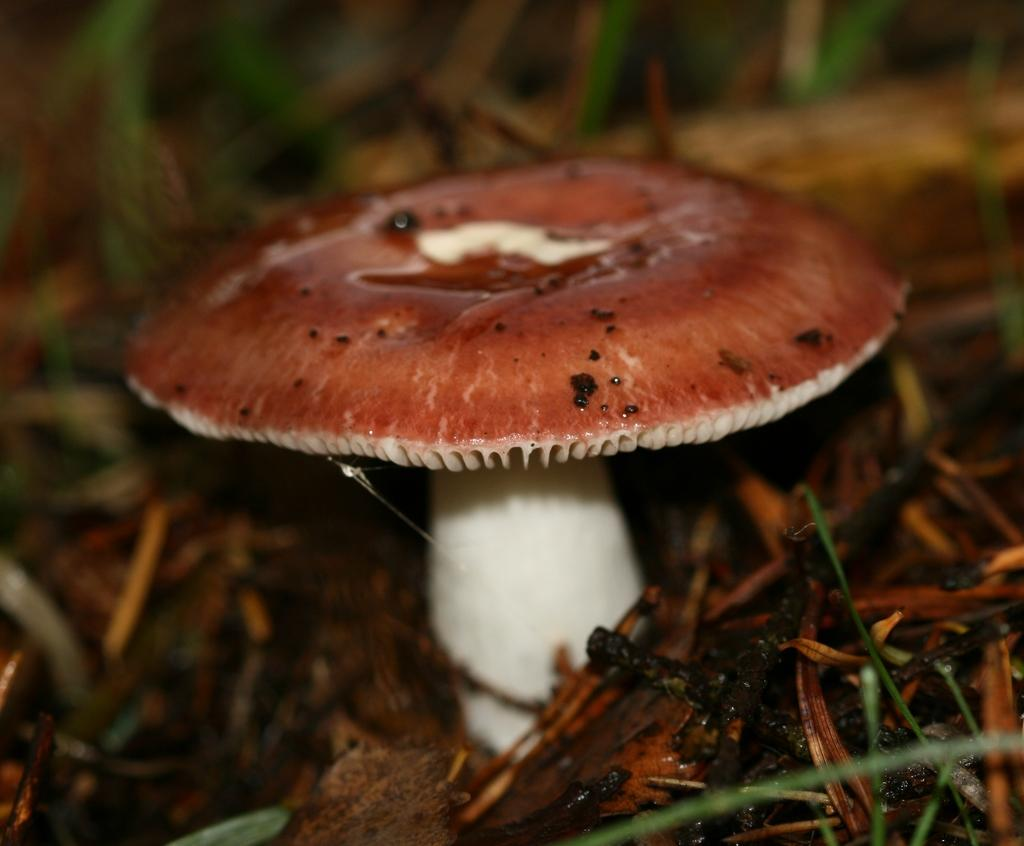What is the main subject of the image? There is a mushroom in the image. Can you describe the background of the image? The background of the image is blurry. How many wings does the mushroom have in the image? The mushroom does not have wings; it is a fungus and not an animal. What type of iron is visible in the image? There is no iron present in the image. 